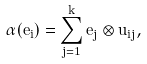<formula> <loc_0><loc_0><loc_500><loc_500>\alpha ( e _ { i } ) = \sum _ { j = 1 } ^ { k } e _ { j } \otimes u _ { i j } ,</formula> 